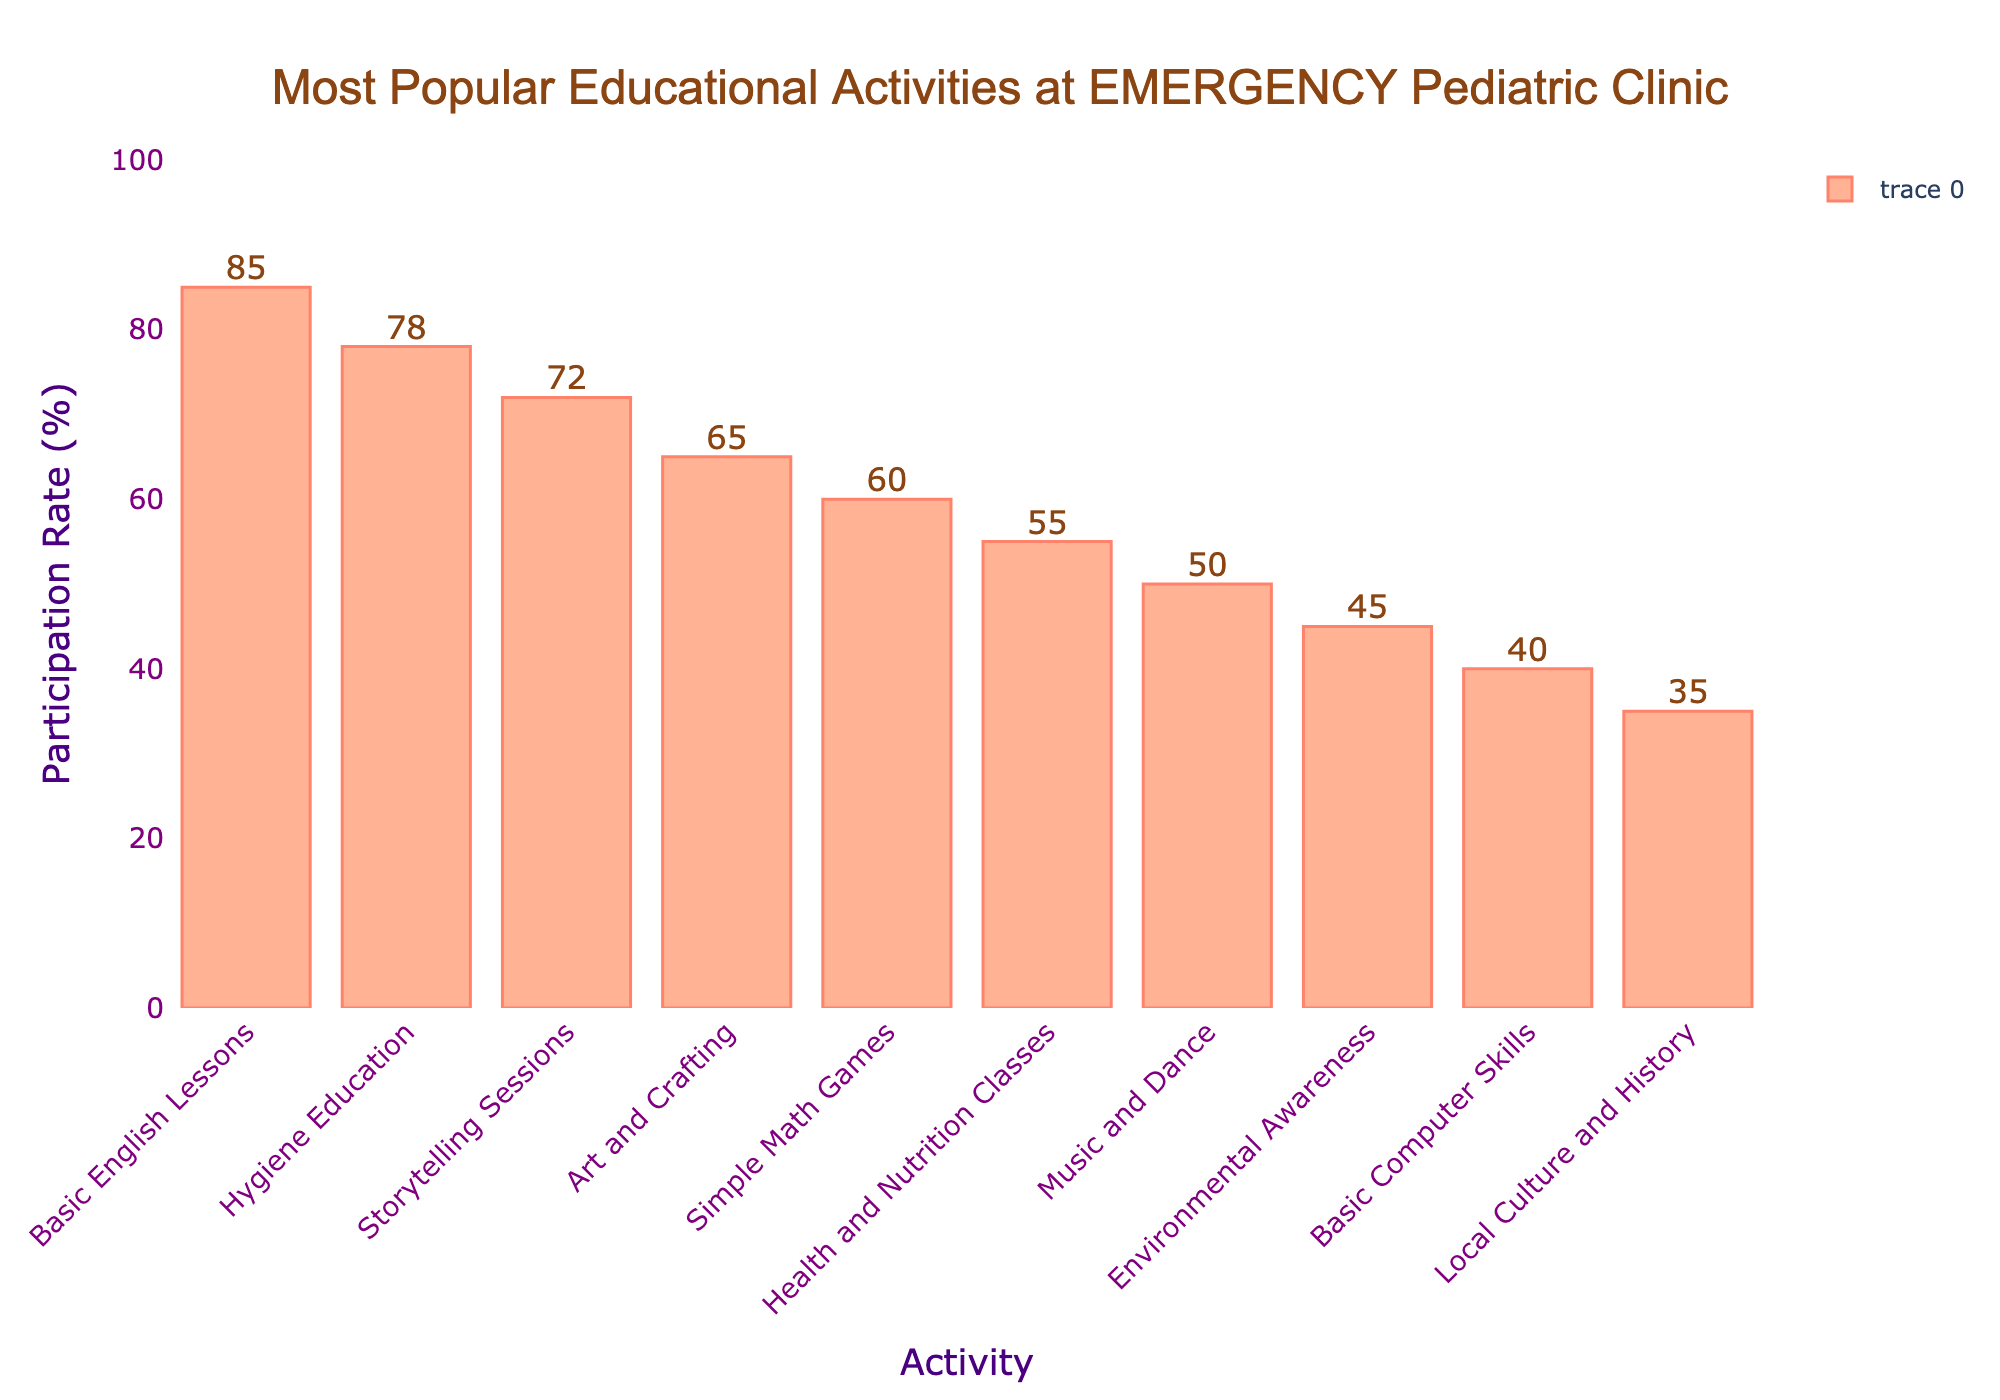What's the most participated activity? By looking at the highest bar, you can see that Basic English Lessons has the highest participation rate at 85%.
Answer: Basic English Lessons Which activity has a lower participation rate: Storytelling Sessions or Art and Crafting? By comparing the heights of the bars, you can see that Storytelling Sessions has a participation rate of 72% while Art and Crafting has 65%.
Answer: Art and Crafting How much higher is the participation rate of Basic English Lessons compared to Music and Dance? Subtract the participation rate of Music and Dance (50%) from Basic English Lessons (85%): 85 - 50 = 35%.
Answer: 35% What is the average participation rate of Health and Nutrition Classes, Music and Dance, and Environmental Awareness? Add the participation rates (55 + 50 + 45) and then divide by 3 to find the average: (55 + 50 + 45) / 3 = 150 / 3 = 50%.
Answer: 50% How many activities have a participation rate of 60% or higher? Count the bars with a height of 60 or more: Basic English Lessons (85%), Hygiene Education (78%), Storytelling Sessions (72%), Art and Crafting (65%), and Simple Math Games (60%) are 5 activities.
Answer: 5 Which activity has the lowest participation rate? By looking at the shortest bar, you can see that Local Culture and History has the lowest participation rate at 35%.
Answer: Local Culture and History What is the total participation rate of the top three activities? Add the participation rates of the top three activities: Basic English Lessons (85%) + Hygiene Education (78%) + Storytelling Sessions (72%) = 235%.
Answer: 235% Are Health and Nutrition Classes more popular than Simple Math Games? By comparing the heights of the bars, you can see that Health and Nutrition Classes have a participation rate of 55% while Simple Math Games is 60%.
Answer: No What is the difference in participation rate between Hygiene Education and Environmental Awareness? Subtract the participation rate of Environmental Awareness (45%) from Hygiene Education (78%): 78 - 45 = 33%.
Answer: 33% Which two activities have the closest participation rates? By comparing the heights of the bars, Simple Math Games and Health and Nutrition Classes have rates of 60% and 55% respectively, with a small difference of just 5%.
Answer: Simple Math Games and Health and Nutrition Classes 